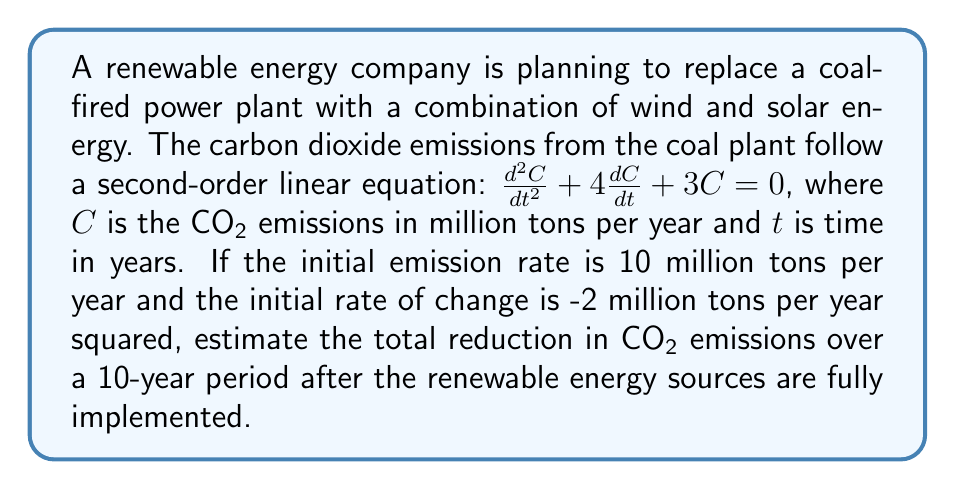Can you solve this math problem? To solve this problem, we need to follow these steps:

1) First, we need to solve the second-order linear equation:
   $\frac{d^2C}{dt^2} + 4\frac{dC}{dt} + 3C = 0$

   The characteristic equation is:
   $r^2 + 4r + 3 = 0$

   Solving this, we get:
   $r = -1$ or $r = -3$

   So, the general solution is:
   $C(t) = A e^{-t} + B e^{-3t}$

2) Now we use the initial conditions to find $A$ and $B$:
   At $t=0$, $C(0) = 10$ and $C'(0) = -2$

   $C(0) = A + B = 10$
   $C'(0) = -A - 3B = -2$

   Solving these simultaneously:
   $A = 7$ and $B = 3$

3) Therefore, the specific solution is:
   $C(t) = 7e^{-t} + 3e^{-3t}$

4) To find the total emissions over 10 years if the coal plant continued operating, we integrate this function from 0 to 10:

   $\int_0^{10} C(t) dt = \int_0^{10} (7e^{-t} + 3e^{-3t}) dt$

   $= [-7e^{-t} - e^{-3t}]_0^{10}$

   $= (-7e^{-10} - e^{-30}) - (-7 - 1)$

   $\approx 7.999$ million tons

5) Since the renewable energy sources are fully implemented, their emissions are assumed to be zero. Therefore, the total reduction in CO₂ emissions over the 10-year period is approximately 7.999 million tons.
Answer: The total reduction in CO₂ emissions over a 10-year period after transitioning to renewable energy sources is approximately 7.999 million tons. 